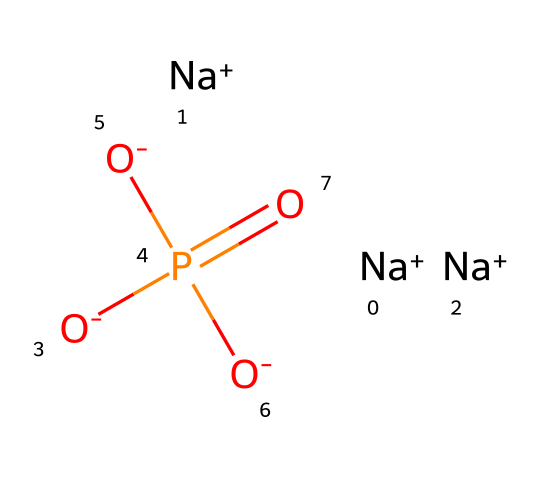What is the central atom in this compound? The central atom in this compound is phosphorus, as indicated by the presence of the P atom in the SMILES representation. It is surrounded by oxygen atoms and is bonded to them.
Answer: phosphorus How many oxygen atoms are present in this compound? By analyzing the SMILES structure, there are four oxygen atoms noted: three are depicted as negatively charged (O-) and one is part of the phosphate (P=O) structure.
Answer: four What is the overall charge of this compound? The overall charge can be determined by considering the charges on the sodium ions and the oxygen atoms. There are three sodium ions each with a +1 charge, and three oxygen atoms each with a -1 charge. Therefore, the compound has a net charge of zero from cancellations.
Answer: zero Is this compound soluble in water? Phosphates, especially those in ionic forms like sodium phosphates, are generally soluble in water, which can be inferred from the presence of sodium ions and negative charges.
Answer: soluble What type of ion is produced when this phosphate dissolves in water? When this phosphate dissolves in water, it produces phosphate ions (PO4^3-) along with sodium ions (Na+), indicating that it dissociates into these components.
Answer: phosphate ion What role do phosphates play in household detergents? Phosphates in detergents mainly act as water softeners and aid in the removal of dirt and stains; they can capture calcium and magnesium ions present in hard water.
Answer: water softeners 